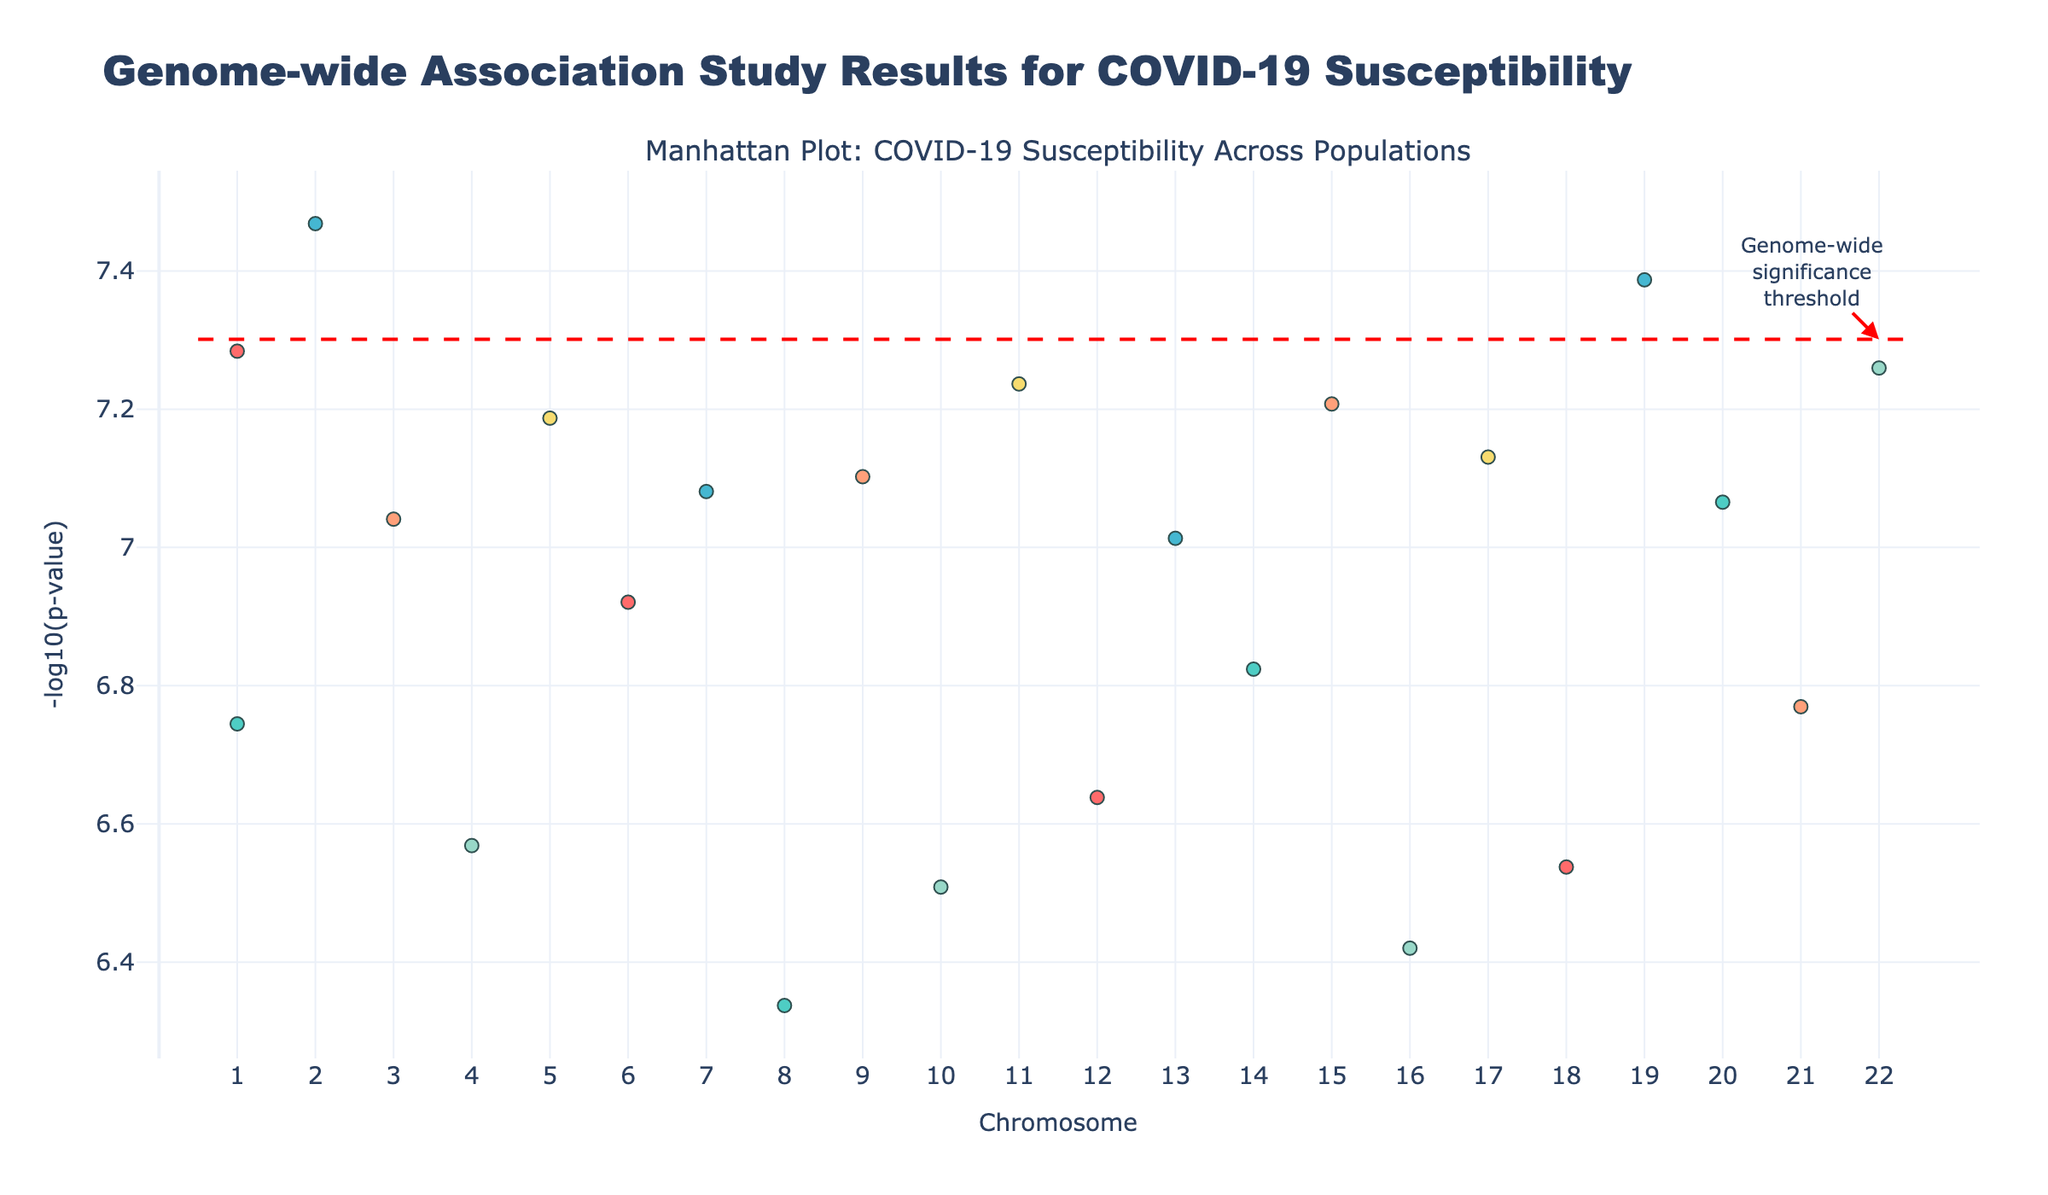What is the title of the Manhattan Plot? The title of the Manhattan Plot is usually placed at the top. In this case, it is "Genome-wide Association Study Results for COVID-19 Susceptibility".
Answer: "Genome-wide Association Study Results for COVID-19 Susceptibility" What do the different colors represent in the plot? The different colors are used to represent different populations. By referring to the legend or the code, the colors include those like red, teal, and yellow, each corresponding to specific populations such as European, Asian, and South Asian.
Answer: Different populations What is the y-axis label in the plot? The y-axis label is found along the vertical axis of the plot. It describes what is being measured, which in this case is "-log10(p-value)".
Answer: "-log10(p-value)" How many SNPs have a p-value below the genome-wide significance threshold? To determine the number of SNPs below the threshold, count the number of data points above the red dashed line, which represents the genome-wide significance threshold of -log10(5e-8).
Answer: 15 Which chromosome has the SNP with the smallest p-value? The SNP with the smallest p-value has the highest vertical position on the plot (largest -log10(p)). By looking at the data points, the highest point corresponds to Chromosome 2.
Answer: Chromosome 2 Which population has the SNP with the highest significance on Chromosome 1? Examine the data points on Chromosome 1 and identify the one with the highest vertical position. The color of this point reveals that it belongs to the European population.
Answer: European Are there more significant SNPs in the European or Asian population? By counting the number of significant data points (above the threshold line) for both European and Asian populations, you can compare the counts.
Answer: European What is the -log10(p-value) of the most significant SNP in the African population? By locating the highest data point among those colored for the African population, you can find its y-axis value. From the code, the highest significant SNP in the African group corresponds to p-value = 4.1e-8, so -log10(4.1e-8) = 7.39.
Answer: 7.39 Between chromosomes 4 and 5, which one has more significant SNPs, and by how many? Count the number of significant data points (above the threshold line) on both Chromosome 4 and 5, and determine the difference.
Answer: Chromosome 5 by 1 Is there any significant SNP found in the Middle Eastern population? To find this, look for any significant data points (above the threshold line) colored for the Middle Eastern population.
Answer: Yes 